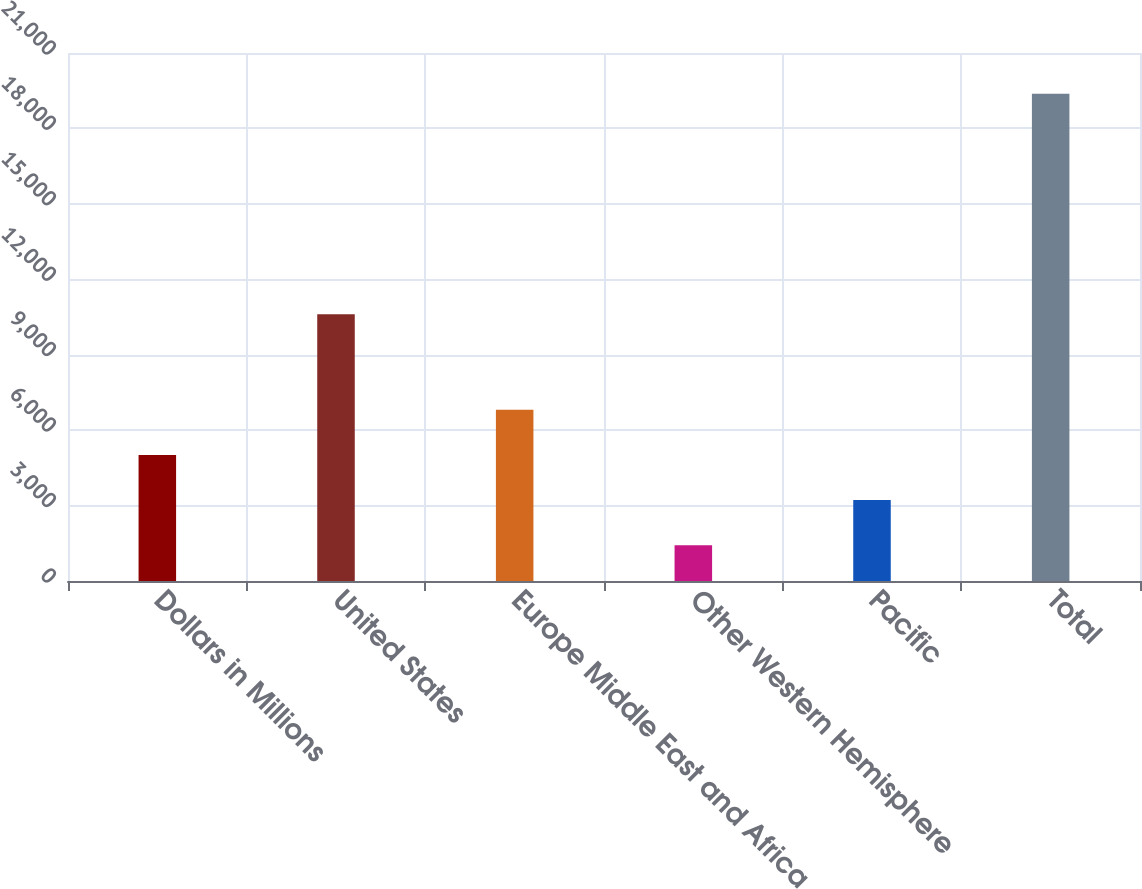<chart> <loc_0><loc_0><loc_500><loc_500><bar_chart><fcel>Dollars in Millions<fcel>United States<fcel>Europe Middle East and Africa<fcel>Other Western Hemisphere<fcel>Pacific<fcel>Total<nl><fcel>5016<fcel>10613<fcel>6811.5<fcel>1425<fcel>3220.5<fcel>19380<nl></chart> 